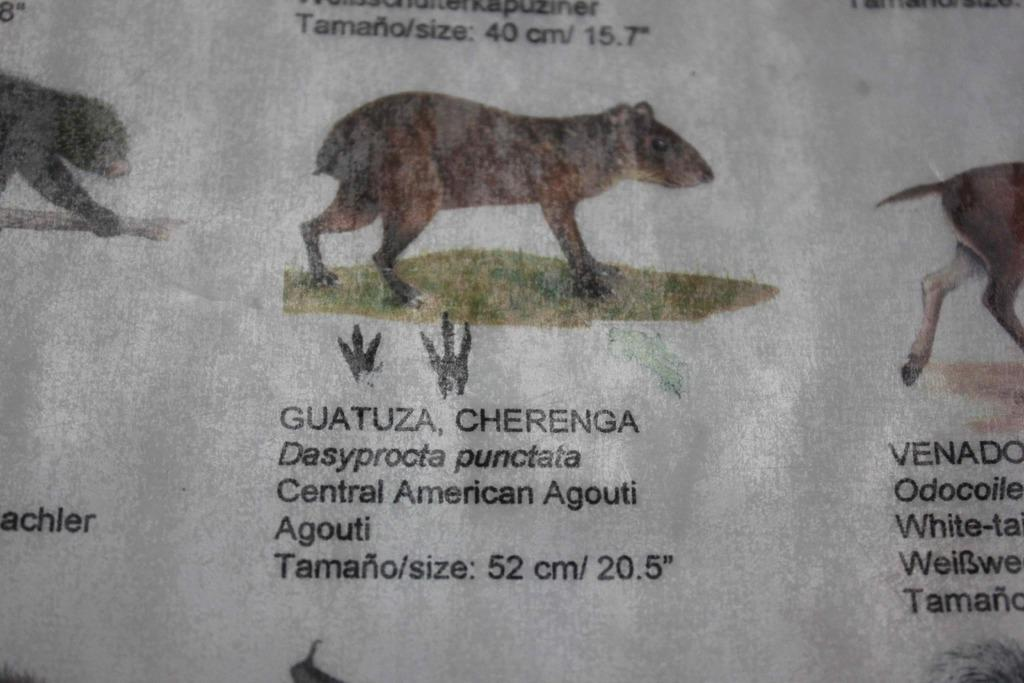What is present on the paper in the image? The paper contains printed images of animals. What else can be seen on the paper besides the images of animals? There is text on the paper. How many icicles are hanging from the paper in the image? There are no icicles present in the image. What type of dinner is being served on the paper in the image? There is no dinner present in the image; it features a paper with printed images of animals and text. What is the weight of the paper in the image? The weight of the paper cannot be determined from the image alone. 